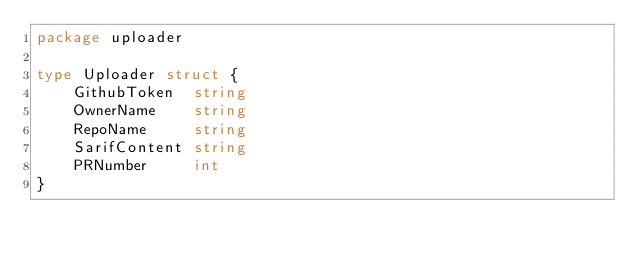<code> <loc_0><loc_0><loc_500><loc_500><_Go_>package uploader

type Uploader struct {
	GithubToken  string
	OwnerName    string
	RepoName     string
	SarifContent string
	PRNumber     int
}
</code> 